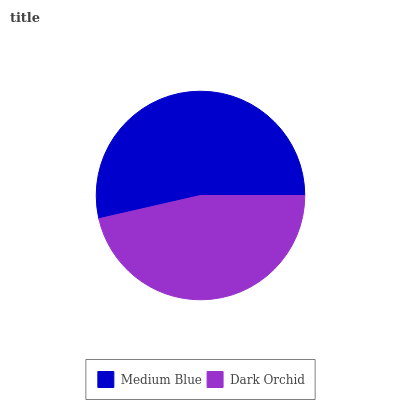Is Dark Orchid the minimum?
Answer yes or no. Yes. Is Medium Blue the maximum?
Answer yes or no. Yes. Is Dark Orchid the maximum?
Answer yes or no. No. Is Medium Blue greater than Dark Orchid?
Answer yes or no. Yes. Is Dark Orchid less than Medium Blue?
Answer yes or no. Yes. Is Dark Orchid greater than Medium Blue?
Answer yes or no. No. Is Medium Blue less than Dark Orchid?
Answer yes or no. No. Is Medium Blue the high median?
Answer yes or no. Yes. Is Dark Orchid the low median?
Answer yes or no. Yes. Is Dark Orchid the high median?
Answer yes or no. No. Is Medium Blue the low median?
Answer yes or no. No. 